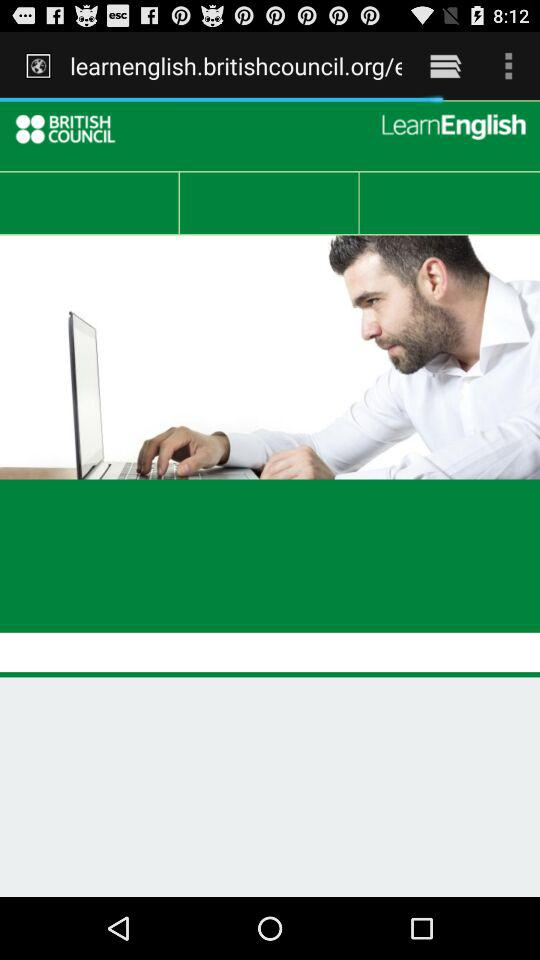What is the application name? The application name is "British Council EnglishScore". 